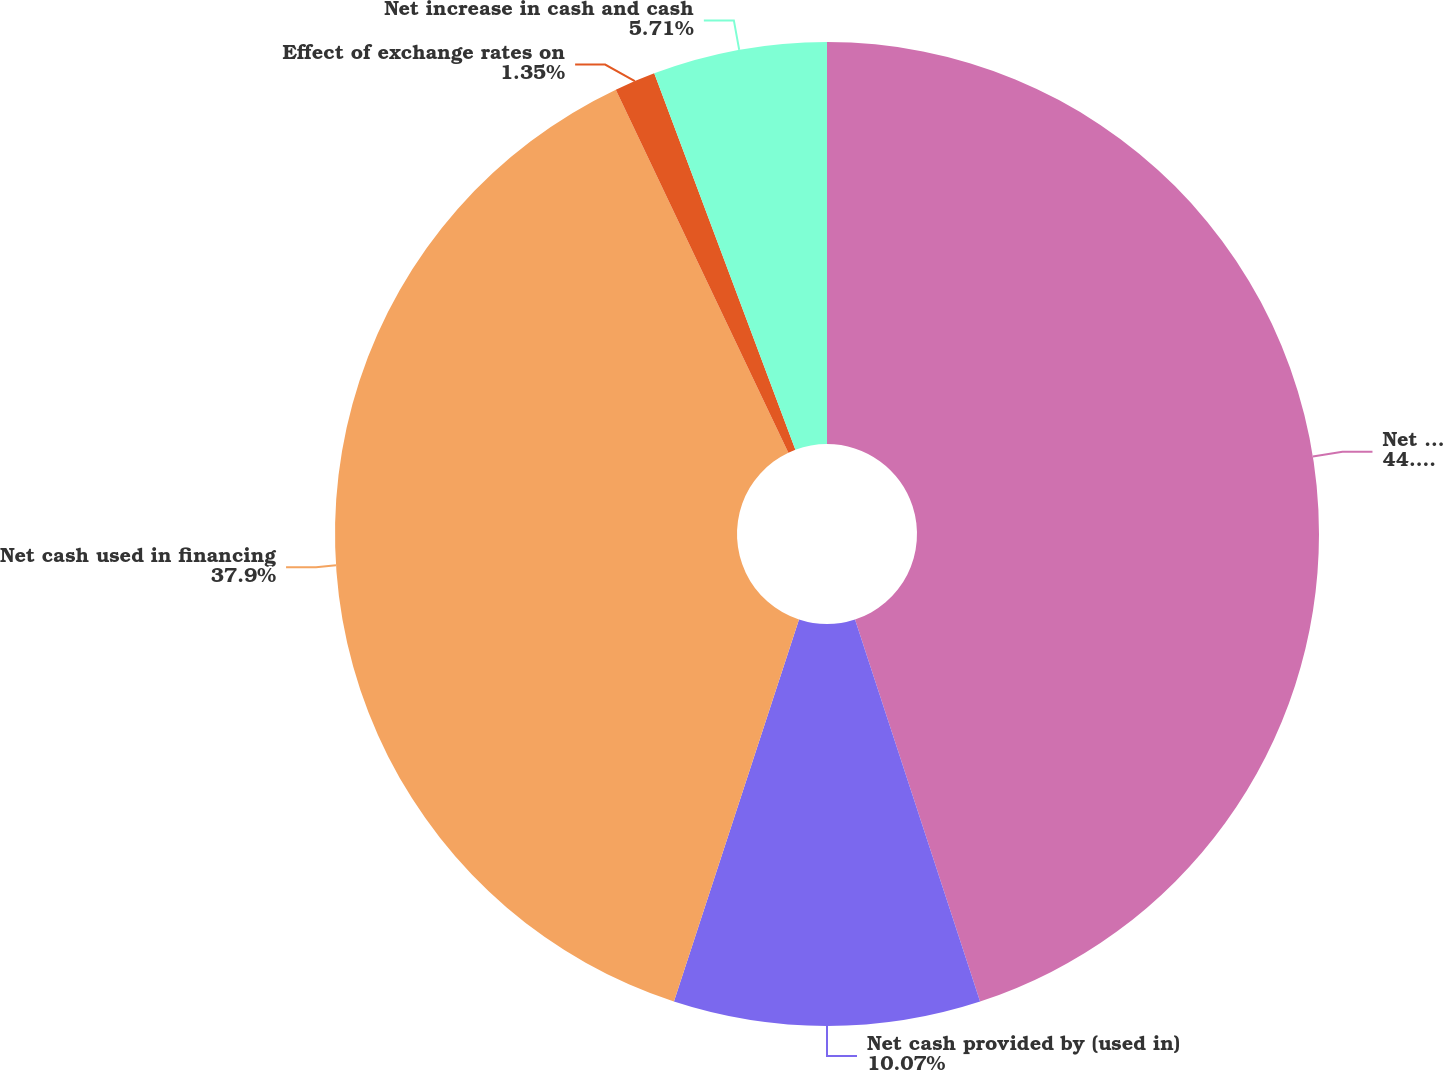<chart> <loc_0><loc_0><loc_500><loc_500><pie_chart><fcel>Net cash provided by operating<fcel>Net cash provided by (used in)<fcel>Net cash used in financing<fcel>Effect of exchange rates on<fcel>Net increase in cash and cash<nl><fcel>44.96%<fcel>10.07%<fcel>37.9%<fcel>1.35%<fcel>5.71%<nl></chart> 